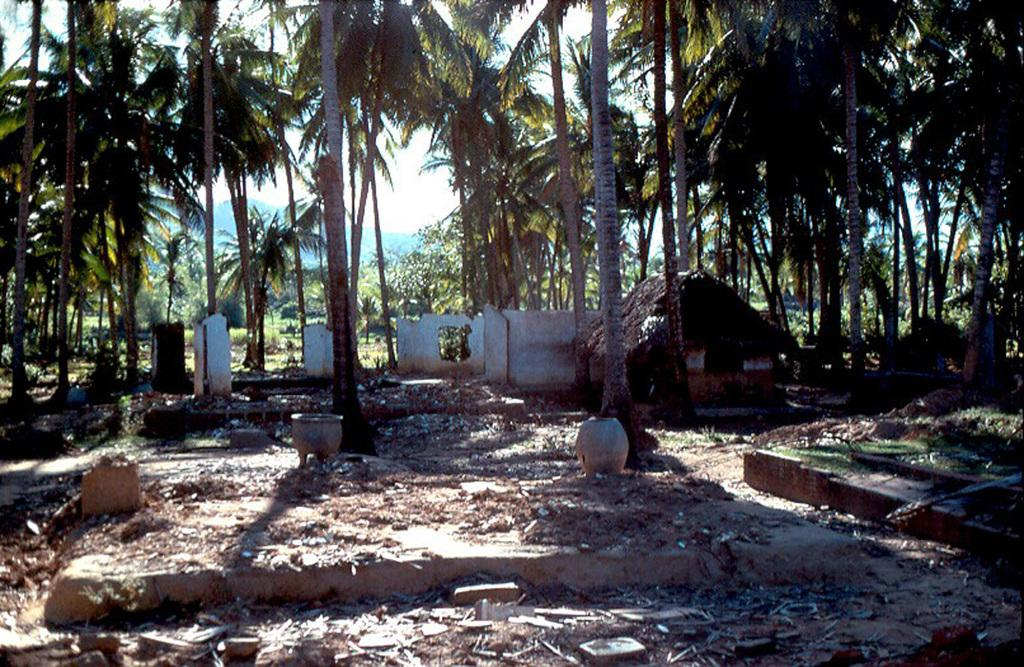What type of structure is visible in the image? There is a hut in the image. What else can be seen in the image besides the hut? There is a wall in the image. What is on the ground in the image? There are leaves and other things on the ground in the image. What can be seen in the background of the image? There are trees and plants in the background of the image. Where is the basin located in the image? There is no basin present in the image. Can you see a baseball game happening in the image? There is no baseball game or any reference to sports in the image. 